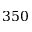Convert formula to latex. <formula><loc_0><loc_0><loc_500><loc_500>3 5 0</formula> 